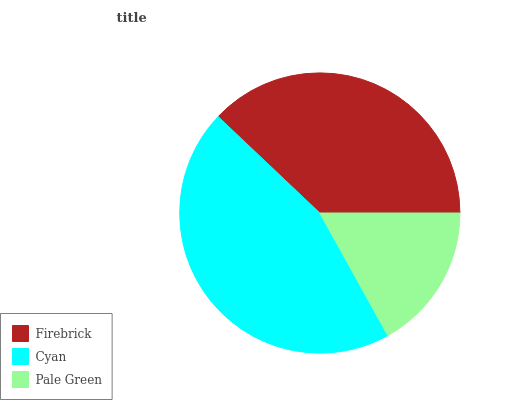Is Pale Green the minimum?
Answer yes or no. Yes. Is Cyan the maximum?
Answer yes or no. Yes. Is Cyan the minimum?
Answer yes or no. No. Is Pale Green the maximum?
Answer yes or no. No. Is Cyan greater than Pale Green?
Answer yes or no. Yes. Is Pale Green less than Cyan?
Answer yes or no. Yes. Is Pale Green greater than Cyan?
Answer yes or no. No. Is Cyan less than Pale Green?
Answer yes or no. No. Is Firebrick the high median?
Answer yes or no. Yes. Is Firebrick the low median?
Answer yes or no. Yes. Is Cyan the high median?
Answer yes or no. No. Is Cyan the low median?
Answer yes or no. No. 